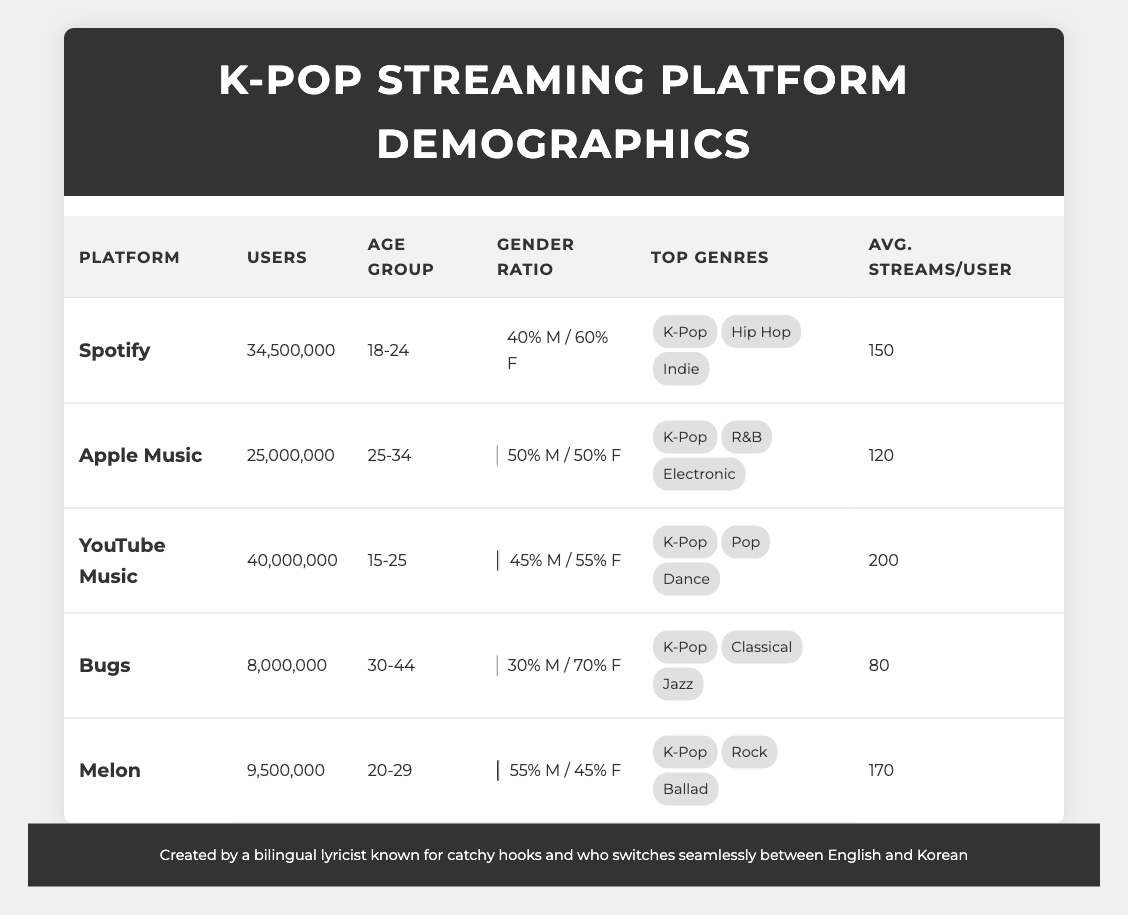What is the user count for YouTube Music? The table lists the number of users for each streaming platform. For YouTube Music, the user count is specifically mentioned as 40,000,000.
Answer: 40,000,000 Which platform has the highest average streams per user? By examining the "Avg. Streams/User" column, Spotify has 150, Apple Music has 120, YouTube Music has 200, Bugs has 80, and Melon has 170. Comparing these values, YouTube Music has the highest average streams per user at 200.
Answer: YouTube Music What percentage of users on Bugs are male? The gender ratio for Bugs indicates that 30% of users are male, as presented in the gender ratio section of the table.
Answer: 30% Which age group has the highest number of total users across all platforms? To answer this, count the users in each age group. The total for 15-25 is 40,000,000 (YouTube Music) + 34,500,000 (Spotify) = 74,500,000. The total for 18-24 is 34,500,000 (Spotify), which is lower than the previous total. The total for 25-34 is 25,000,000 (Apple Music), lower still. The total for 30-44 is 8,000,000 (Bugs), and 20-29 is 9,500,000 (Melon). Therefore, 15-25 has the highest total with 74,500,000 users.
Answer: 15-25 Is the gender ratio on Apple Music evenly split? The table presents Apple Music's gender ratio as 50% male and 50% female, indicating an even split.
Answer: Yes What are the top three genres for Spotify? The table shows that Spotify's top genres include K-Pop, Hip Hop, and Indie. These genres are listed directly in the "Top Genres" section.
Answer: K-Pop, Hip Hop, Indie Which platform has the lowest user count, and what is that count? Looking at the user counts in the table, Bugs has the lowest user count at 8,000,000 users.
Answer: Bugs, 8,000,000 How many total users listen to K-Pop across all platforms? The user counts for K-Pop are: Spotify with 34,500,000, Apple Music with 25,000,000, YouTube Music with 40,000,000, Bugs with 8,000,000, and Melon with 9,500,000. Summing these gives 34,500,000 + 25,000,000 + 40,000,000 + 8,000,000 + 9,500,000 = 117,000,000.
Answer: 117,000,000 What is the average percentage of female users across all platforms? To calculate this, summing the female percentages: Spotify has 60%, Apple Music has 50%, YouTube Music has 55%, Bugs has 70%, and Melon has 45%. The total is 60 + 50 + 55 + 70 + 45 = 280%. Dividing this by 5 (the number of platforms), the average is 280/5 = 56%.
Answer: 56% 